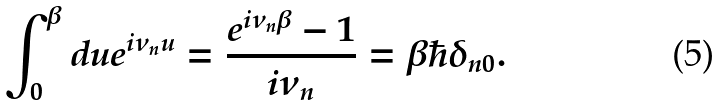Convert formula to latex. <formula><loc_0><loc_0><loc_500><loc_500>\int _ { 0 } ^ { \beta } d u e ^ { i \nu _ { n } u } = \frac { e ^ { i \nu _ { n } \beta } - 1 } { i \nu _ { n } } = \beta \hbar { \delta } _ { n 0 } .</formula> 